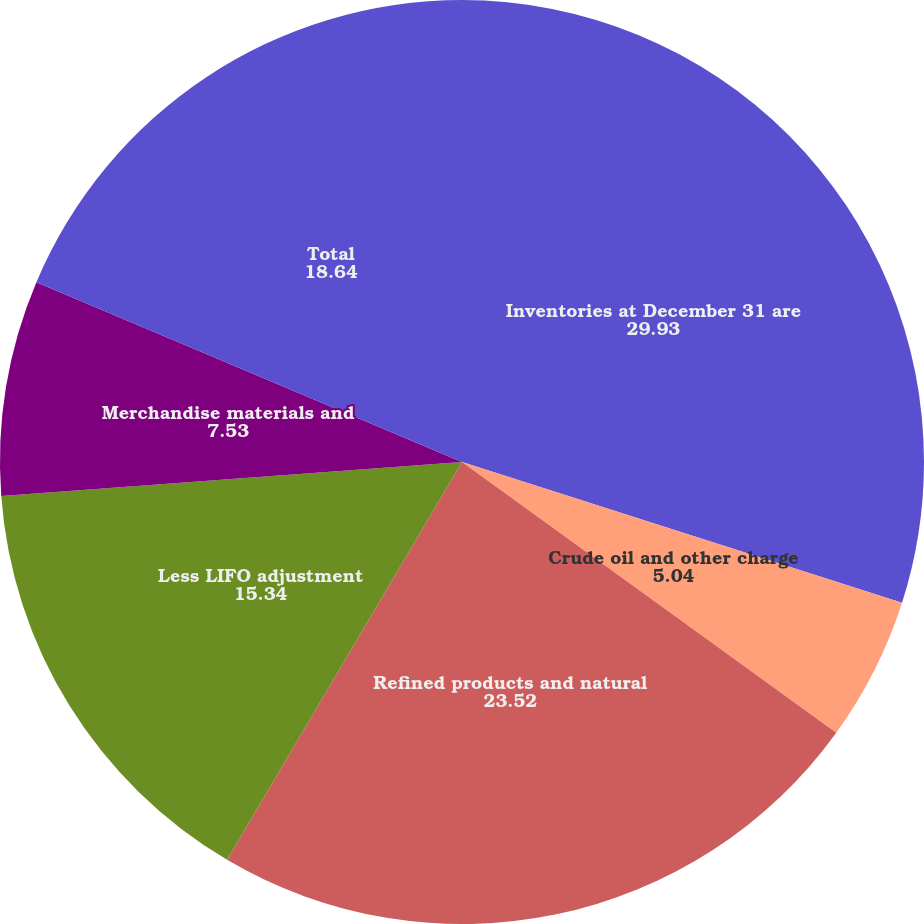Convert chart. <chart><loc_0><loc_0><loc_500><loc_500><pie_chart><fcel>Inventories at December 31 are<fcel>Crude oil and other charge<fcel>Refined products and natural<fcel>Less LIFO adjustment<fcel>Merchandise materials and<fcel>Total<nl><fcel>29.93%<fcel>5.04%<fcel>23.52%<fcel>15.34%<fcel>7.53%<fcel>18.64%<nl></chart> 